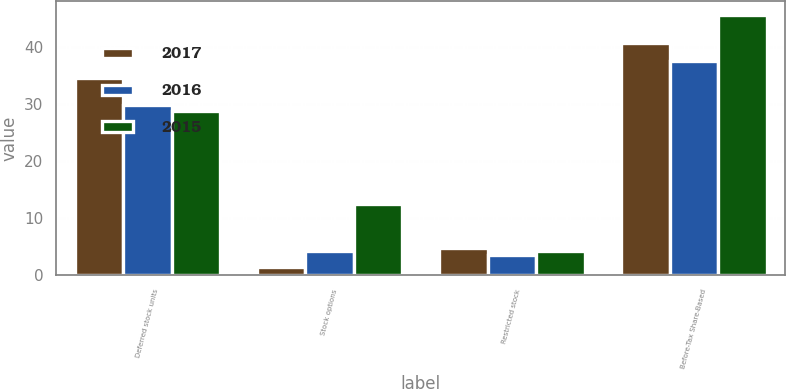Convert chart. <chart><loc_0><loc_0><loc_500><loc_500><stacked_bar_chart><ecel><fcel>Deferred stock units<fcel>Stock options<fcel>Restricted stock<fcel>Before-Tax Share-Based<nl><fcel>2017<fcel>34.5<fcel>1.4<fcel>4.8<fcel>40.7<nl><fcel>2016<fcel>29.9<fcel>4.2<fcel>3.5<fcel>37.6<nl><fcel>2015<fcel>28.8<fcel>12.6<fcel>4.3<fcel>45.7<nl></chart> 